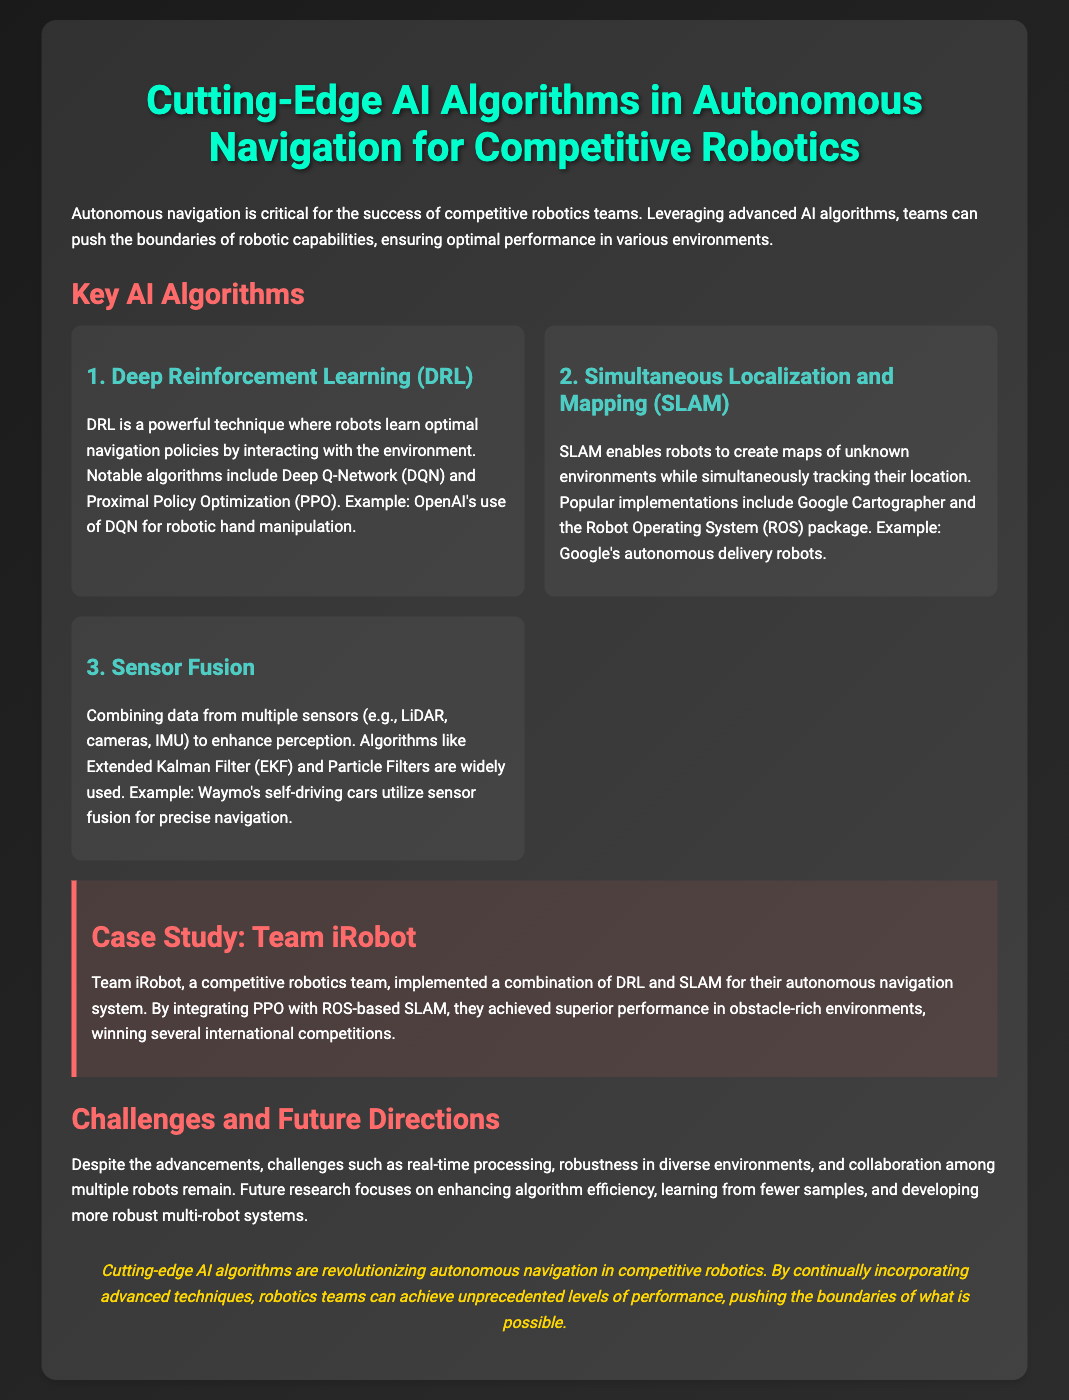What is the title of the presentation? The title is prominently displayed at the top of the slide, summarizing the main topic.
Answer: Cutting-Edge AI Algorithms in Autonomous Navigation for Competitive Robotics What does DRL stand for? The acronym for the first key AI algorithm mentioned in the document is defined in the description.
Answer: Deep Reinforcement Learning What algorithm is used by Team iRobot? The document specifies the algorithms combined by Team iRobot for their autonomous navigation system.
Answer: DRL and SLAM Which algorithm is associated with Google's autonomous delivery robots? The document explicitly discusses an algorithm used by Google's technology for a specific application.
Answer: SLAM What is one of the challenges mentioned in the document? The presentation outlines various challenges faced in the field, highlighting one significant issue.
Answer: Real-time processing How many international competitions did Team iRobot win? The document mentions the achievements of Team iRobot, including their competition success.
Answer: Several What is one focus of future research? The document lists goals for future research directions in autonomous navigation, including improving efficiency.
Answer: Enhancing algorithm efficiency What does SLAM stand for? The acronym for the second key AI algorithm described in the document is presented in the content.
Answer: Simultaneous Localization and Mapping 